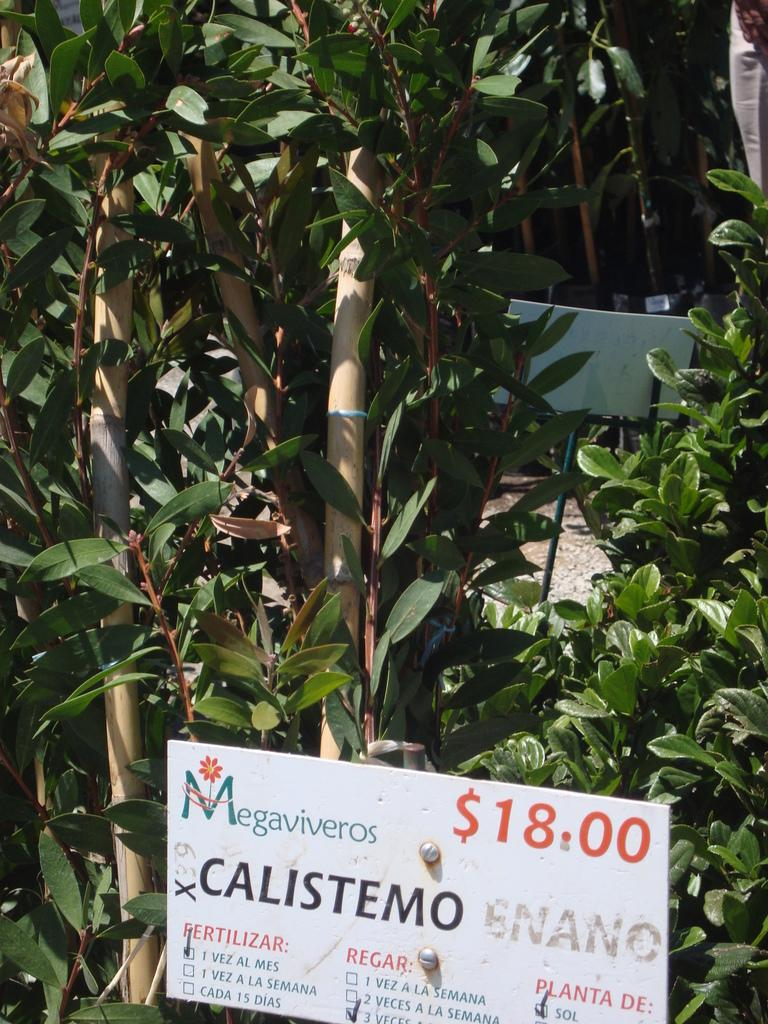What type of living organisms can be seen in the image? Plants can be seen in the image. What is located at the bottom of the image? There is a board at the bottom of the image. What is written on the board? The board contains some text. Can you see a squirrel sitting on the plants in the image? There is no squirrel present in the image; it only features plants and a board with text. 